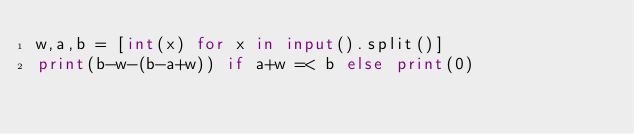Convert code to text. <code><loc_0><loc_0><loc_500><loc_500><_Python_>w,a,b = [int(x) for x in input().split()]
print(b-w-(b-a+w)) if a+w =< b else print(0)</code> 